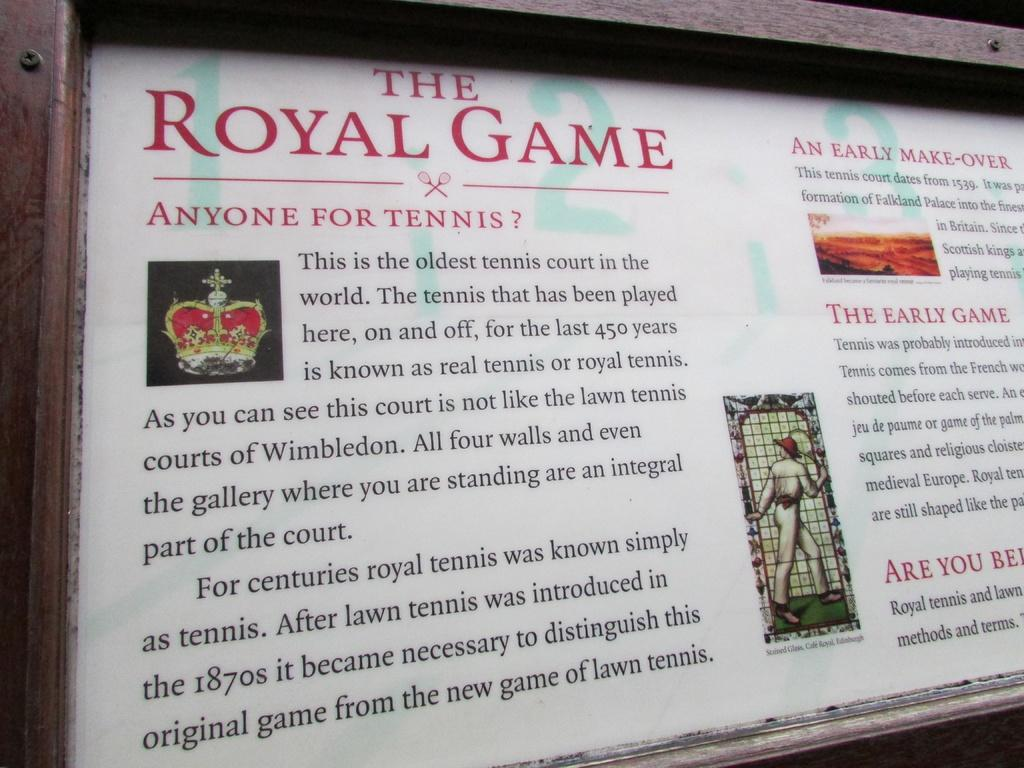<image>
Describe the image concisely. A large white sign that says The Royal Game. 